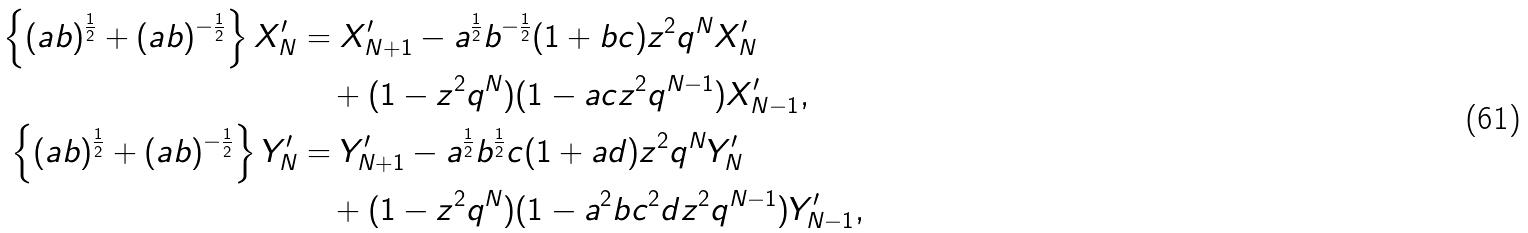Convert formula to latex. <formula><loc_0><loc_0><loc_500><loc_500>\left \{ ( a b ) ^ { \frac { 1 } { 2 } } + ( a b ) ^ { - \frac { 1 } { 2 } } \right \} X _ { N } ^ { \prime } & = X _ { N + 1 } ^ { \prime } - a ^ { \frac { 1 } { 2 } } b ^ { - \frac { 1 } { 2 } } ( 1 + b c ) z ^ { 2 } q ^ { N } X _ { N } ^ { \prime } \\ & \quad + ( 1 - z ^ { 2 } q ^ { N } ) ( 1 - a c z ^ { 2 } q ^ { N - 1 } ) X _ { N - 1 } ^ { \prime } , \\ \left \{ ( a b ) ^ { \frac { 1 } { 2 } } + ( a b ) ^ { - \frac { 1 } { 2 } } \right \} Y _ { N } ^ { \prime } & = Y _ { N + 1 } ^ { \prime } - a ^ { \frac { 1 } { 2 } } b ^ { \frac { 1 } { 2 } } c ( 1 + a d ) z ^ { 2 } q ^ { N } Y _ { N } ^ { \prime } \\ & \quad + ( 1 - z ^ { 2 } q ^ { N } ) ( 1 - a ^ { 2 } b c ^ { 2 } d z ^ { 2 } q ^ { N - 1 } ) Y _ { N - 1 } ^ { \prime } ,</formula> 